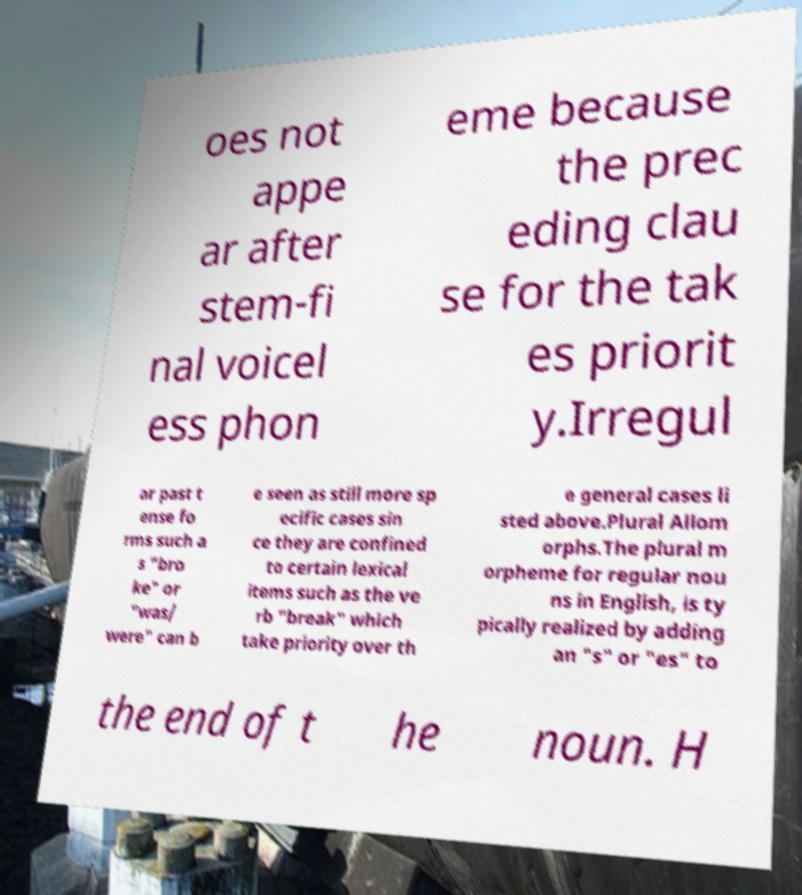Please identify and transcribe the text found in this image. oes not appe ar after stem-fi nal voicel ess phon eme because the prec eding clau se for the tak es priorit y.Irregul ar past t ense fo rms such a s "bro ke" or "was/ were" can b e seen as still more sp ecific cases sin ce they are confined to certain lexical items such as the ve rb "break" which take priority over th e general cases li sted above.Plural Allom orphs.The plural m orpheme for regular nou ns in English, is ty pically realized by adding an "s" or "es" to the end of t he noun. H 